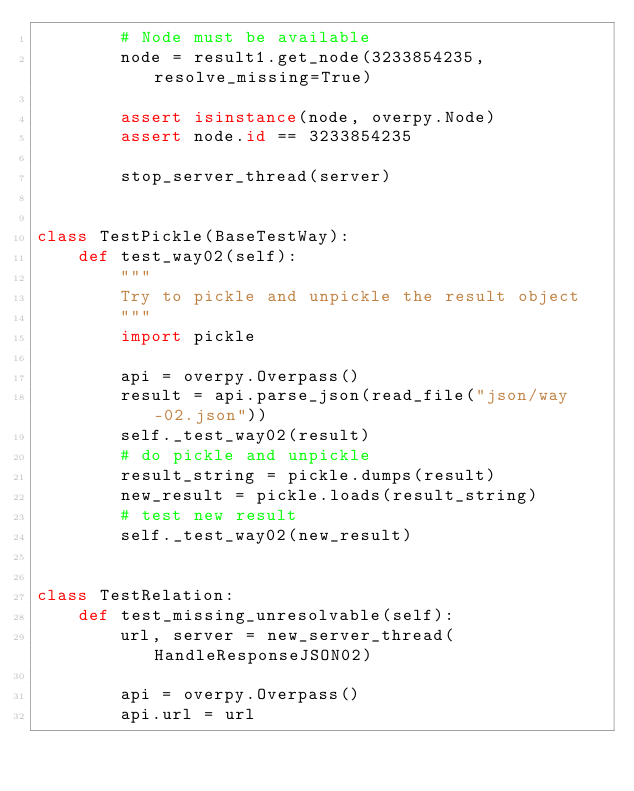Convert code to text. <code><loc_0><loc_0><loc_500><loc_500><_Python_>        # Node must be available
        node = result1.get_node(3233854235, resolve_missing=True)

        assert isinstance(node, overpy.Node)
        assert node.id == 3233854235

        stop_server_thread(server)


class TestPickle(BaseTestWay):
    def test_way02(self):
        """
        Try to pickle and unpickle the result object
        """
        import pickle

        api = overpy.Overpass()
        result = api.parse_json(read_file("json/way-02.json"))
        self._test_way02(result)
        # do pickle and unpickle
        result_string = pickle.dumps(result)
        new_result = pickle.loads(result_string)
        # test new result
        self._test_way02(new_result)


class TestRelation:
    def test_missing_unresolvable(self):
        url, server = new_server_thread(HandleResponseJSON02)

        api = overpy.Overpass()
        api.url = url</code> 